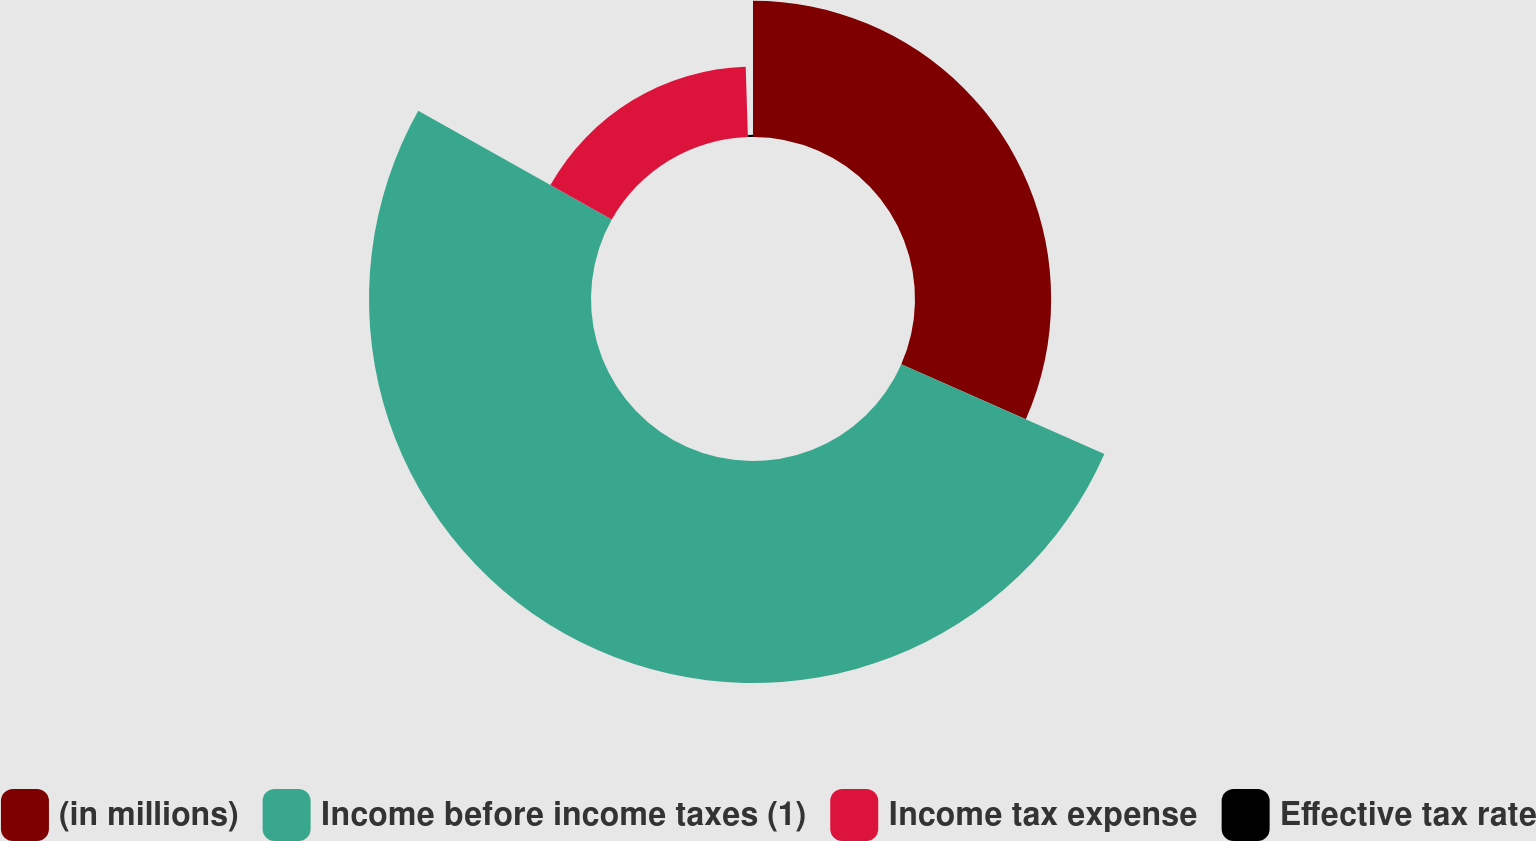Convert chart to OTSL. <chart><loc_0><loc_0><loc_500><loc_500><pie_chart><fcel>(in millions)<fcel>Income before income taxes (1)<fcel>Income tax expense<fcel>Effective tax rate<nl><fcel>31.61%<fcel>51.54%<fcel>16.35%<fcel>0.5%<nl></chart> 